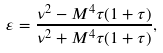Convert formula to latex. <formula><loc_0><loc_0><loc_500><loc_500>\varepsilon = \frac { \nu ^ { 2 } - M ^ { 4 } \tau ( 1 + \tau ) } { \nu ^ { 2 } + M ^ { 4 } \tau ( 1 + \tau ) } ,</formula> 